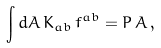Convert formula to latex. <formula><loc_0><loc_0><loc_500><loc_500>\int d A \, K _ { a b } \, f ^ { a b } = P \, A \, ,</formula> 